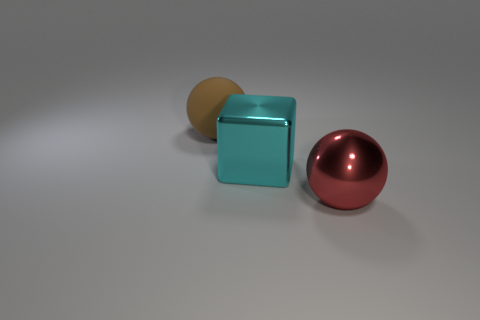What kind of atmosphere or mood does the image convey? The image conveys a calm and minimalist atmosphere, with a neutral background and a small number of objects placed in an orderly fashion, creating a sense of simplicity and balance. 